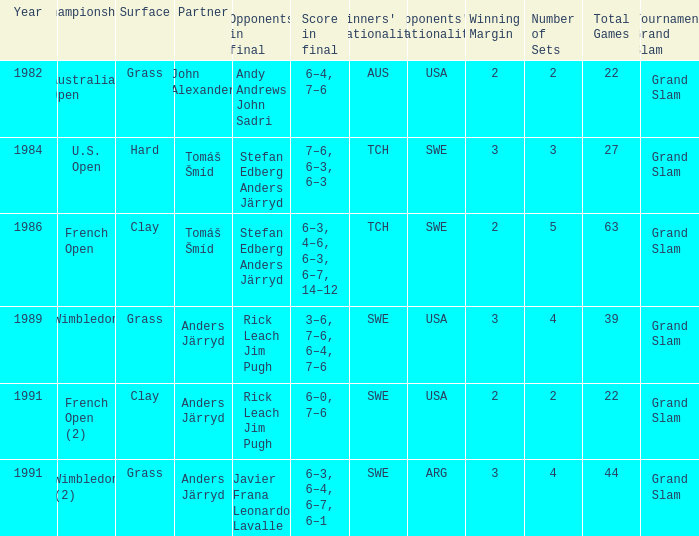Who was his partner in 1989?  Anders Järryd. 